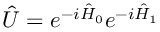<formula> <loc_0><loc_0><loc_500><loc_500>\hat { U } = e ^ { - i \hat { H } _ { 0 } } e ^ { - i \hat { H } _ { 1 } }</formula> 